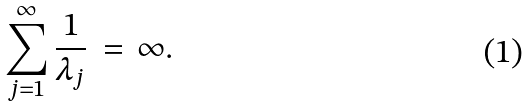<formula> <loc_0><loc_0><loc_500><loc_500>\sum _ { j = 1 } ^ { \infty } \frac { 1 } { \lambda _ { j } } \, = \, \infty .</formula> 